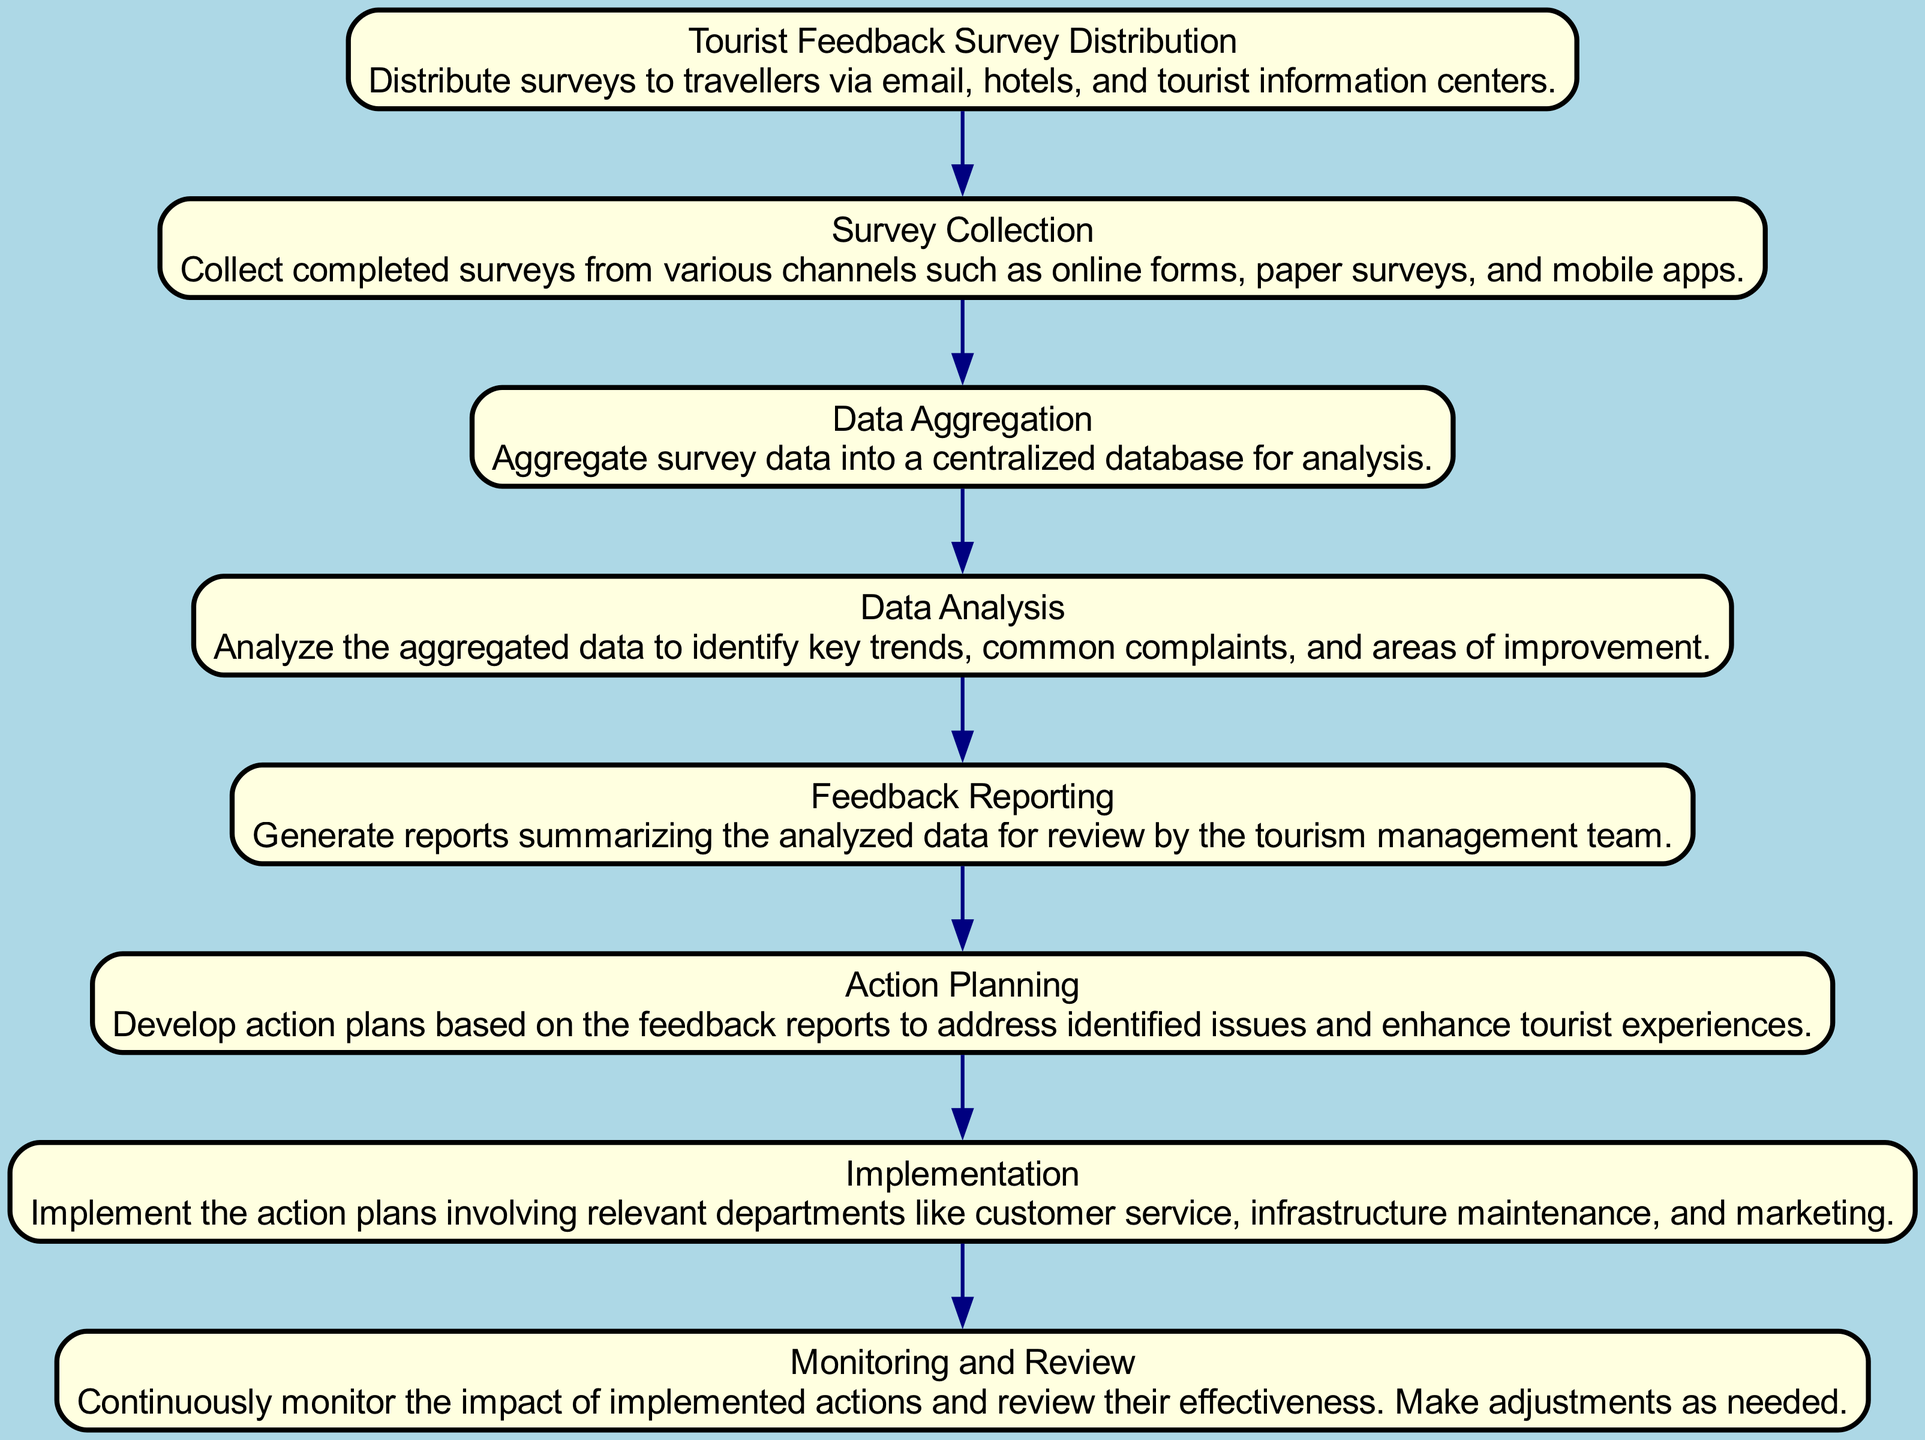What is the first step in the process? The first step, as indicated in the diagram, is "Tourist Feedback Survey Distribution," which is the initial action taken to gather feedback.
Answer: Tourist Feedback Survey Distribution How many nodes are there in the diagram? The diagram has eight nodes, representing each key stage in the feedback capture and response process. Count them directly from the visual representation.
Answer: Eight What follows "Data Analysis" in the process? According to the diagram, "Feedback Reporting" comes after "Data Analysis," showing the flow from analyzing data to reporting it for review.
Answer: Feedback Reporting Which step involves creating actionable strategies? The step that involves creating actionable strategies is "Action Planning," where plans are developed based on the feedback reports.
Answer: Action Planning Which departments are involved during "Implementation"? The diagram specifies that relevant departments like customer service, infrastructure maintenance, and marketing are involved in the "Implementation" of action plans.
Answer: Customer service, infrastructure maintenance, and marketing What is the last step in the process? The last step of the process, as depicted in the diagram, is "Monitoring and Review," which focuses on evaluating the effectiveness of implemented actions.
Answer: Monitoring and Review If feedback is collected, which step follows immediately? Immediately after feedback is collected, the next step is "Data Aggregation," indicating the transition from data gathering to preparation for analysis.
Answer: Data Aggregation What is the purpose of "Feedback Reporting"? The purpose of "Feedback Reporting" is to generate reports summarizing the analyzed data for review by the tourism management team, allowing for informed decisions based on feedback.
Answer: Generate reports Why is "Monitoring and Review" critical? "Monitoring and Review" is critical as it ensures that the impacts of implemented actions are continuously evaluated and adjusted as needed, making it essential for ongoing improvement.
Answer: Continuous improvement 